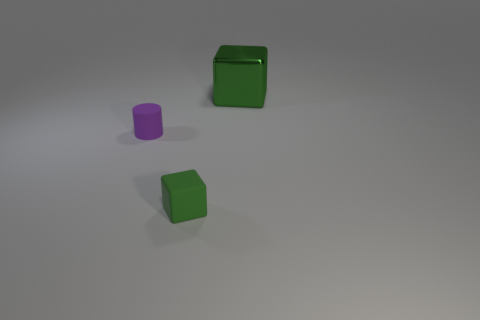Are there any other things that are the same size as the purple rubber cylinder?
Give a very brief answer. Yes. What material is the cube that is behind the matte thing right of the small cylinder?
Offer a very short reply. Metal. Are there an equal number of large green metal things that are in front of the green matte cube and large green shiny objects that are in front of the purple rubber cylinder?
Make the answer very short. Yes. What number of objects are either green objects on the left side of the large metal thing or rubber objects that are to the right of the purple rubber cylinder?
Your answer should be very brief. 1. There is a object that is both on the right side of the small purple matte object and to the left of the big object; what material is it made of?
Provide a succinct answer. Rubber. There is a green object that is in front of the rubber thing that is behind the green block that is in front of the green metallic cube; what is its size?
Make the answer very short. Small. Is the number of green blocks greater than the number of green matte blocks?
Provide a succinct answer. Yes. Does the block that is to the left of the big thing have the same material as the tiny purple thing?
Ensure brevity in your answer.  Yes. Are there fewer small blocks than red blocks?
Provide a short and direct response. No. Are there any big green objects that are behind the matte object to the right of the tiny matte object left of the small rubber block?
Ensure brevity in your answer.  Yes. 